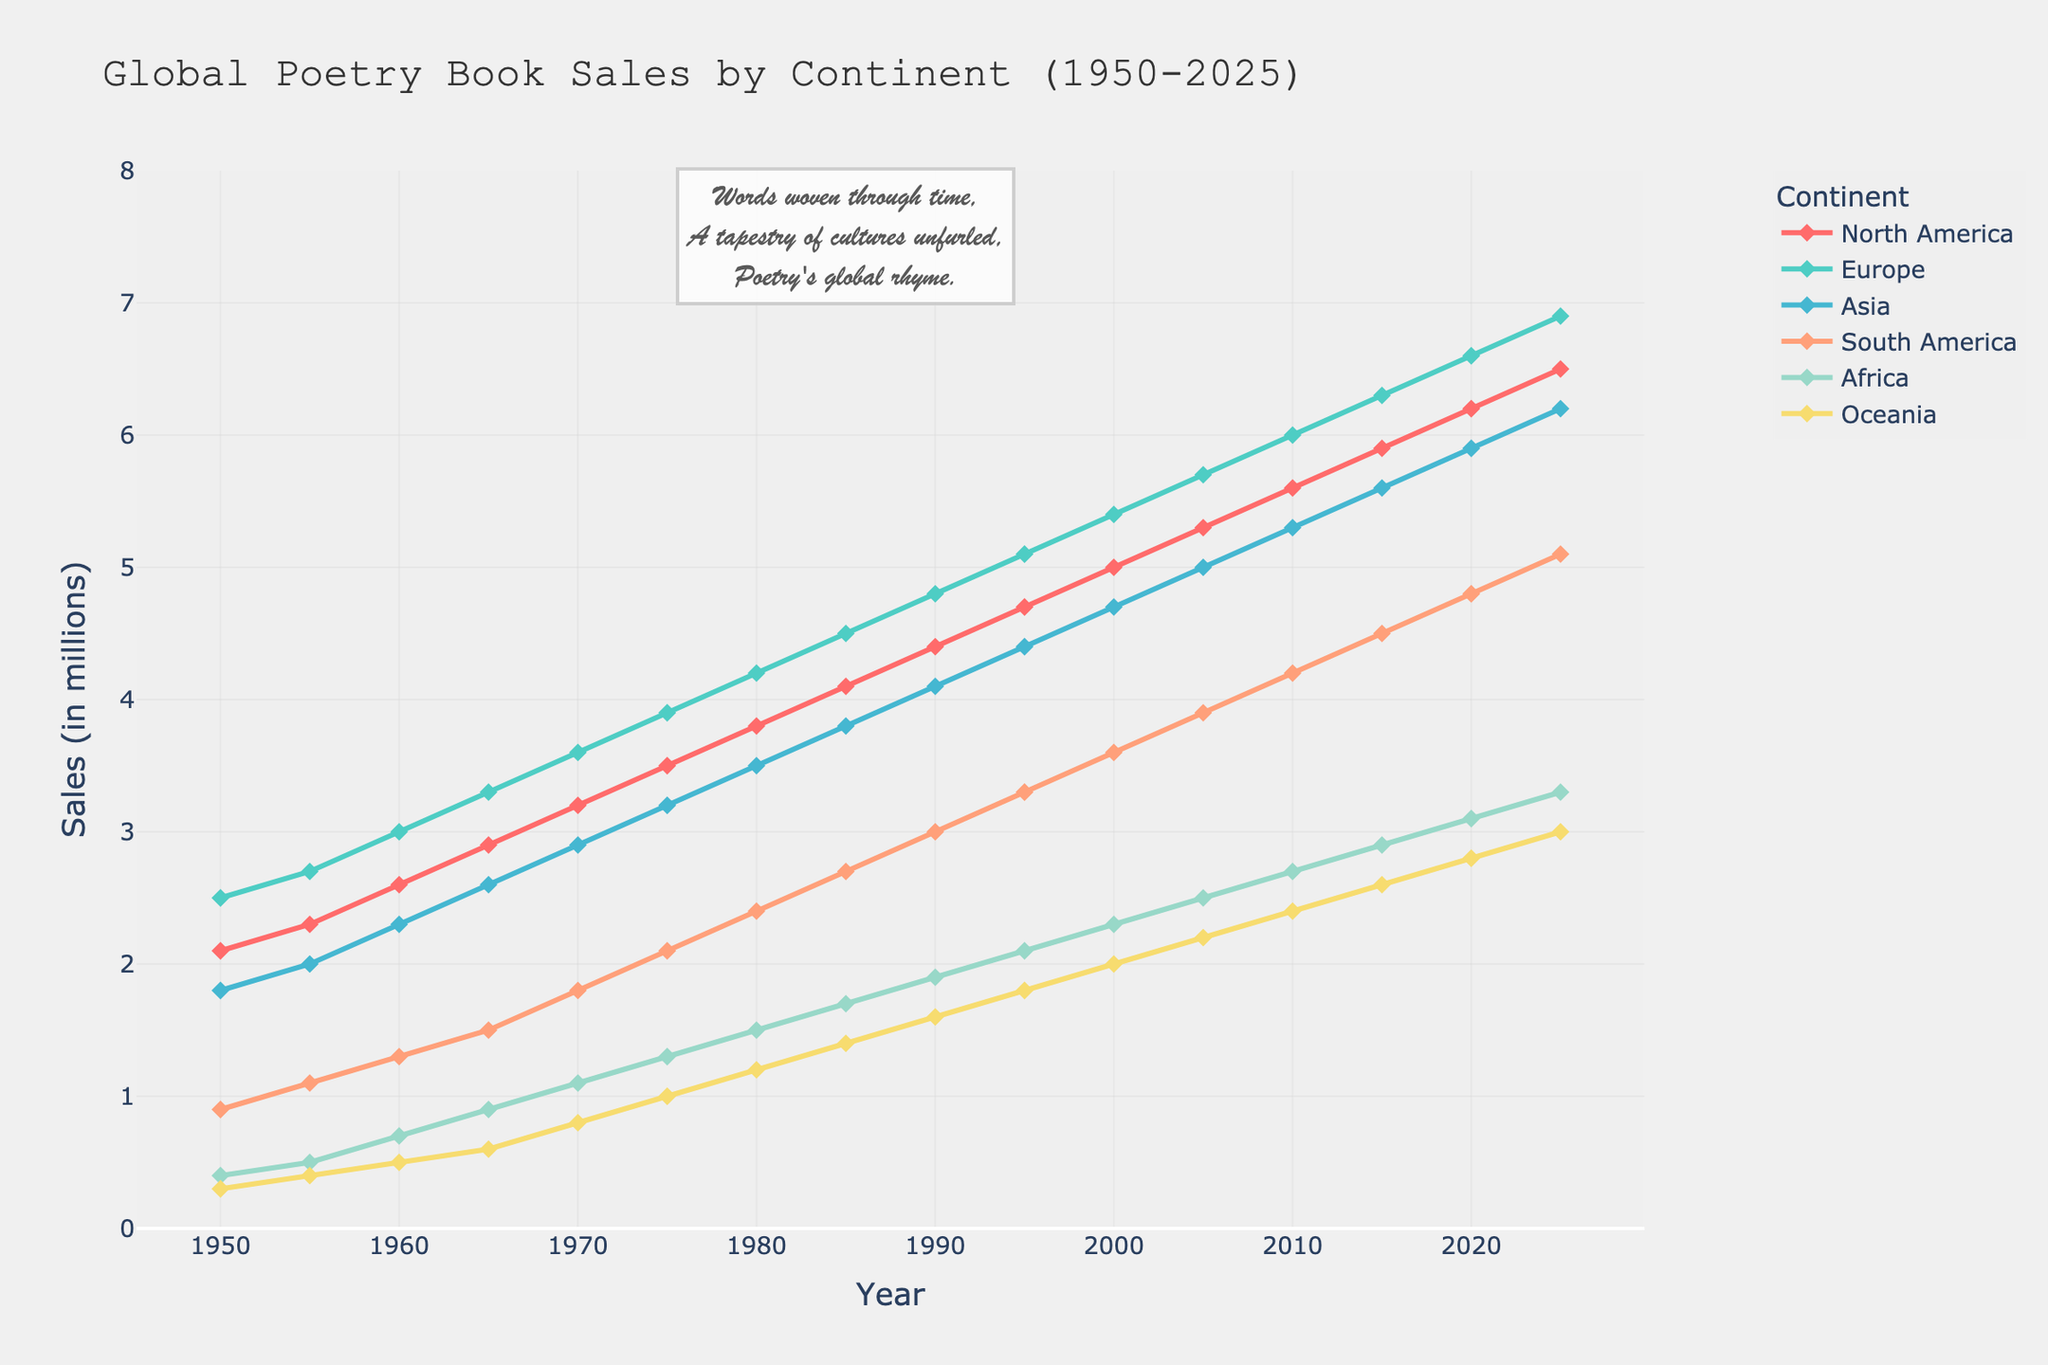What's the general trend of global poetry book sales in North America from 1950 to 2025? The general trend for poetry book sales in North America is increasing. Starting at 2.1 million in 1950 and reaching 6.5 million in 2025. The increase appears gradual and steady over the years.
Answer: Increasing In which year did Europe surpass 5 million poetry book sales? Europe surpassed 5 million poetry book sales in 1995. By observing the Europe data series, we can see that the value jumps from 4.8 million in 1990 to 5.1 million in 1995.
Answer: 1995 Compare the poetry book sales in Asia and South America in 2020. Which continent had higher sales and by how much? In 2020, Asia had 5.9 million poetry book sales, whereas South America had 4.8 million. Asia's sales are higher than South America's by 1.1 million.
Answer: Asia, 1.1 million What is the average growth rate per decade in Oceania's poetry book sales from 1950 to 2025? From 1950 (0.3 million) to 2025 (3.0 million), there are 75 years or 7.5 decades; Oceania's sales growth is (3.0 - 0.3) = 2.7 million. The average growth rate per decade is 2.7 million / 7.5 decades, which equals 0.36 million per decade.
Answer: 0.36 million per decade What are the poetry book sales in Africa in 2000, and how does this compare with Europe in the same year? In 2000, Africa had 2.3 million poetry book sales, while Europe had 5.4 million. Europe's sales are higher than Africa's by 3.1 million.
Answer: Africa: 2.3 million, Europe: 3.1 million higher Which continent shows the steepest rate of increase in poetry book sales around 1965 to 1975? From 1965 to 1975, Europe increased from 3.3 million to 3.9 million, which is an increase of 0.6 million. Other continents experienced smaller increments in the same period, making Europe's rate of 0.6 million the steepest.
Answer: Europe Between 1995 and 2005, which continent experienced the largest increase in poetry book sales? Between 1995 and 2005, Asia experienced an increase from 4.4 million to 5.0 million, which is 0.6 million. By comparing this with the sales increments of other continents over the same period, Asia's increase is the largest.
Answer: Asia Analyze the change in poetry book sales in South America from 1980 to 2000. What is the percentage increase over these years? South America sales in 1980 were 2.4 million, and in 2000, they were 3.6 million. The increase is 1.2 million. The percentage increase is (1.2 million / 2.4 million) * 100, which equals 50%.
Answer: 50% Which continents had nearly equal poetry book sales in 1960 and what were those sales figures? In 1960, North America had 2.6 million sales, and Asia had 2.3 million sales. These figures are relatively close compared to other continents in the dataset.
Answer: North America: 2.6 million, Asia: 2.3 million How do the sales trends from 1950 to 1960 compare for Africa and Oceania? From 1950 to 1960, Africa's poetry book sales increased from 0.4 million to 0.7 million, and Oceania's increased from 0.3 million to 0.5 million. Both continents show a gradual increase, but Africa had a slightly larger increase in absolute terms (0.3 million vs. 0.2 million for Oceania).
Answer: Africa: higher increase, Oceania: lower increase 